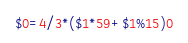<code> <loc_0><loc_0><loc_500><loc_500><_Awk_>$0=4/3*($1*59+$1%15)0</code> 